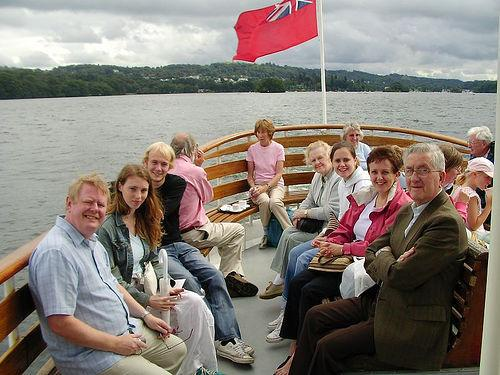What group of people are they likely to be? tourists 